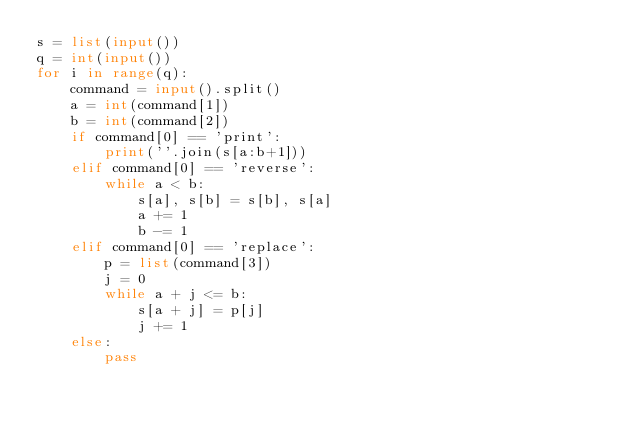Convert code to text. <code><loc_0><loc_0><loc_500><loc_500><_Python_>s = list(input())
q = int(input())
for i in range(q):
    command = input().split()
    a = int(command[1])
    b = int(command[2])
    if command[0] == 'print':
        print(''.join(s[a:b+1]))
    elif command[0] == 'reverse':
        while a < b:
            s[a], s[b] = s[b], s[a]
            a += 1
            b -= 1
    elif command[0] == 'replace':
        p = list(command[3])
        j = 0
        while a + j <= b:
            s[a + j] = p[j]
            j += 1
    else:
        pass

</code> 